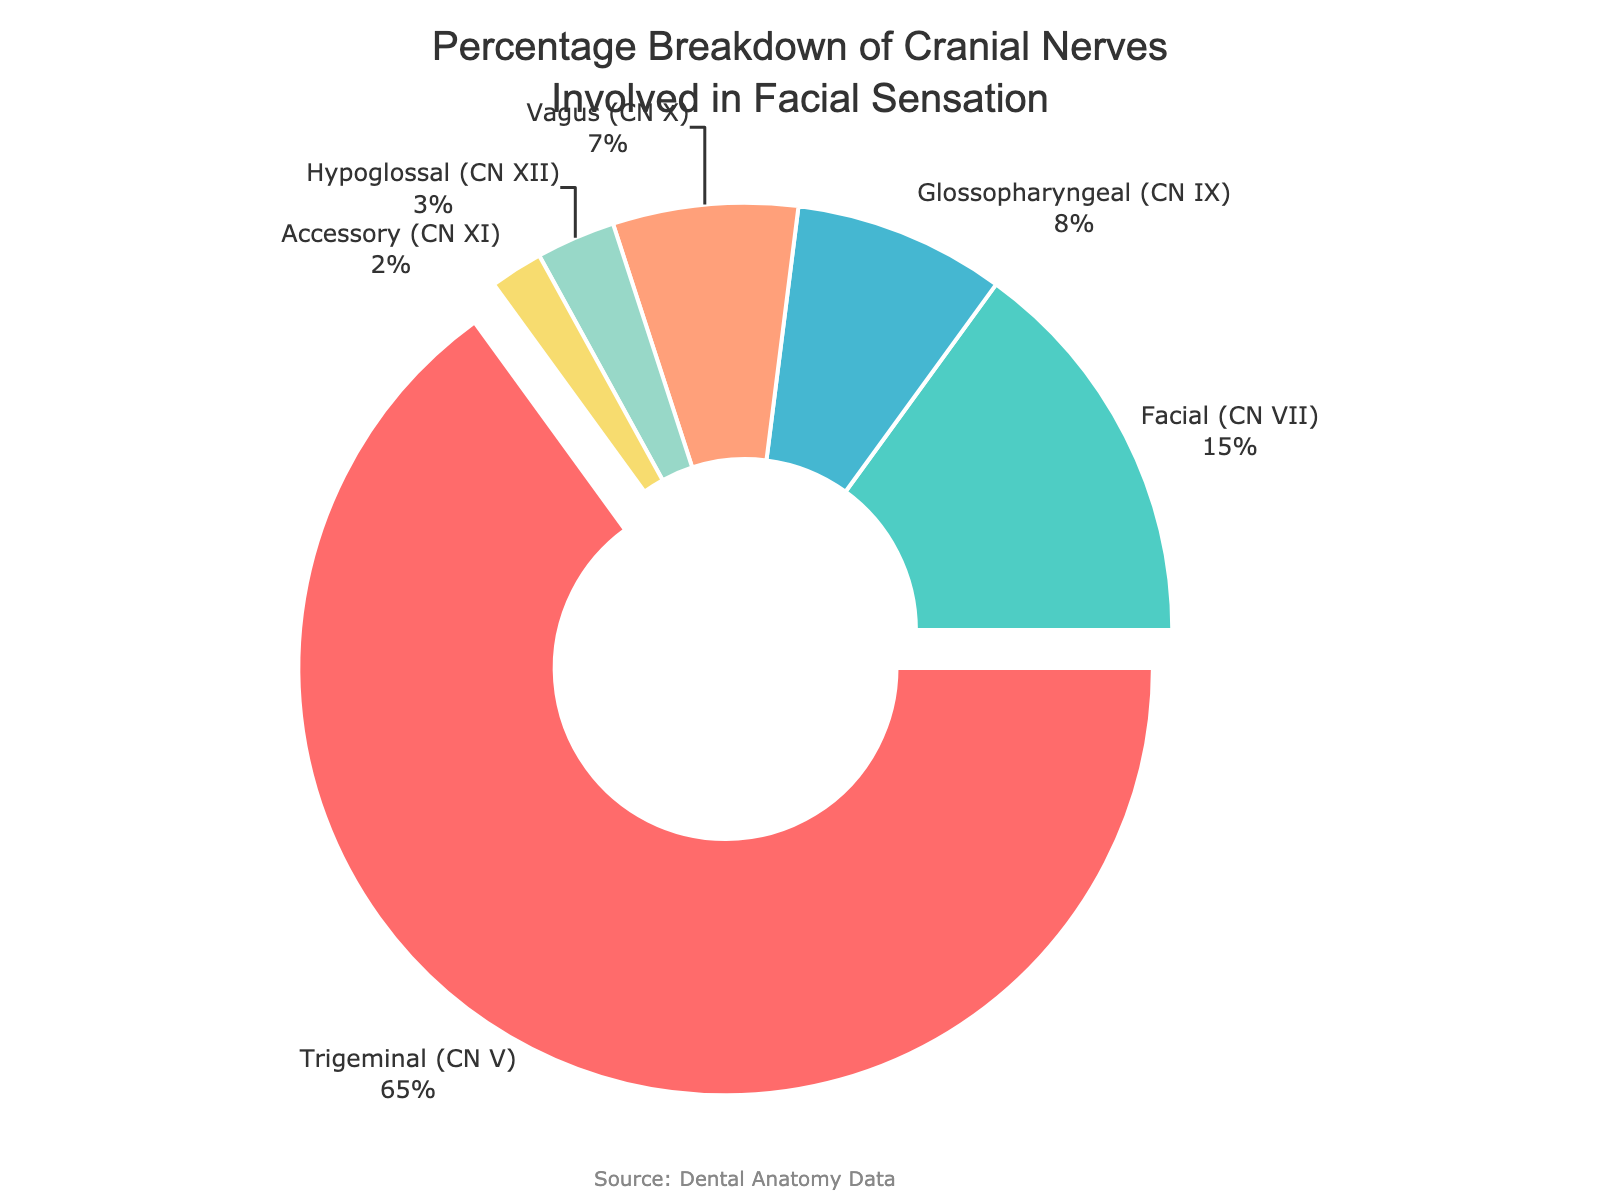Which cranial nerve is responsible for the largest percentage of facial sensation? The segment with the largest percentage in the pie chart represents the Trigeminal nerve (CN V), as identified by its size and associated percentage.
Answer: Trigeminal (CN V) Which two cranial nerves combined are responsible for an equal or larger percentage than the Facial nerve (CN VII)? The Facial nerve (CN VII) accounts for 15%. The Glossopharyngeal (CN IX) and Vagus (CN X) nerves, combined, account for 8% + 7% = 15%, matching the contribution of the Facial nerve.
Answer: Glossopharyngeal (CN IX) and Vagus (CN X) Which cranial nerve has the smallest percentage in facial sensation, and what is this percentage? The segment with the smallest area and percentage (2%) is associated with the Accessory nerve (CN XI).
Answer: Accessory (CN XI), 2% What is the total percentage covered by cranial nerves other than the Trigeminal nerve (CN V)? To find the total percentage, sum the percentages of all cranial nerves except the Trigeminal nerve: 15% + 8% + 7% + 3% + 2% = 35%.
Answer: 35% How does the percentage of the Hypoglossal nerve (CN XII) compare to the Facial nerve (CN VII)? The Hypoglossal nerve (CN XII) has a percentage of 3%, while the Facial nerve (CN VII) represents 15%. Therefore, the Facial nerve's percentage is 12% more.
Answer: Facial (CN VII) is 12% more What is the difference in percentage between the Vagus nerve (CN X) and Glossopharyngeal nerve (CN IX)? The percentage for the Glossopharyngeal nerve (CN IX) is 8%, while the Vagus nerve (CN X) is 7%. The difference is 8% - 7% = 1%.
Answer: 1% What is the percentage contribution of cranial nerves involved in facial sensation represented by colors other than red? The Trigeminal nerve (CN V) segment is red, contributing 65%. Therefore, the rest of the chart contributes 100% - 65% = 35%.
Answer: 35% Which cranial nerve has the second-highest percentage in facial sensation, and what is this percentage? The second-largest segment in the pie chart, after the Trigeminal nerve (CN V) at 65%, is the Facial nerve (CN VII) at 15%.
Answer: Facial (CN VII), 15% What is the average percentage of sensation controlled by Glossopharyngeal (CN IX), Vagus (CN X), and Hypoglossal (CN XII) nerves? Sum the percentages for these three nerves: 8% + 7% + 3% = 18%. Then, divide by 3 for the average: 18% / 3 = 6%.
Answer: 6% If another cranial nerve were discovered to also contribute to facial sensation at 10%, how would this affect the percentage of the Trigeminal nerve (CN V)? The new total percentage including the added nerve would be 100% + 10% = 110%. The new contribution of the Trigeminal nerve (CN V) would be recalculated: (65% / 110%) * 100% ≈ 59.09%.
Answer: Approximately 59.09% 